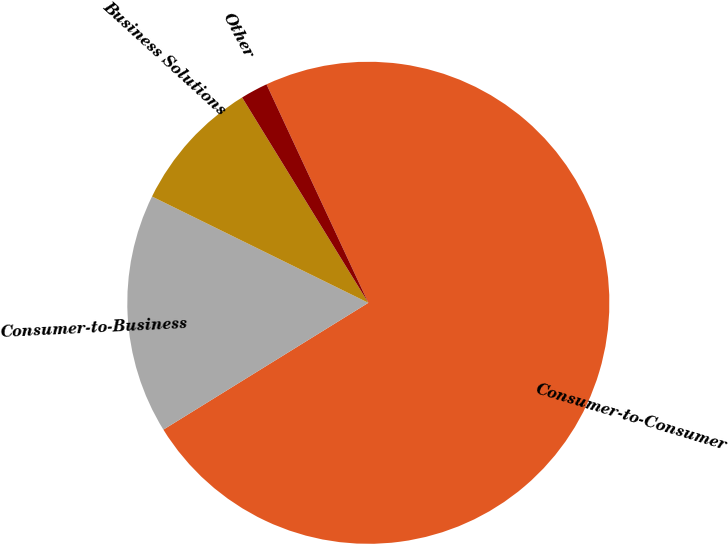Convert chart. <chart><loc_0><loc_0><loc_500><loc_500><pie_chart><fcel>Consumer-to-Consumer<fcel>Consumer-to-Business<fcel>Business Solutions<fcel>Other<nl><fcel>73.13%<fcel>16.09%<fcel>8.96%<fcel>1.83%<nl></chart> 